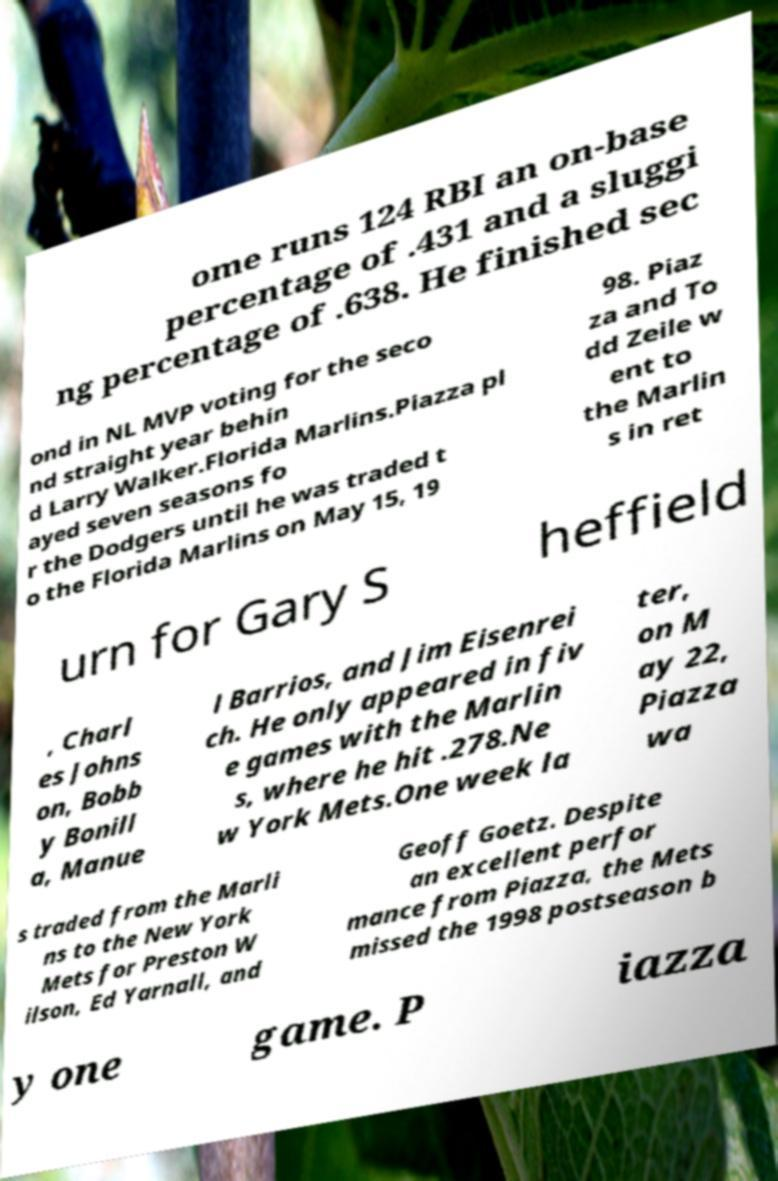There's text embedded in this image that I need extracted. Can you transcribe it verbatim? ome runs 124 RBI an on-base percentage of .431 and a sluggi ng percentage of .638. He finished sec ond in NL MVP voting for the seco nd straight year behin d Larry Walker.Florida Marlins.Piazza pl ayed seven seasons fo r the Dodgers until he was traded t o the Florida Marlins on May 15, 19 98. Piaz za and To dd Zeile w ent to the Marlin s in ret urn for Gary S heffield , Charl es Johns on, Bobb y Bonill a, Manue l Barrios, and Jim Eisenrei ch. He only appeared in fiv e games with the Marlin s, where he hit .278.Ne w York Mets.One week la ter, on M ay 22, Piazza wa s traded from the Marli ns to the New York Mets for Preston W ilson, Ed Yarnall, and Geoff Goetz. Despite an excellent perfor mance from Piazza, the Mets missed the 1998 postseason b y one game. P iazza 